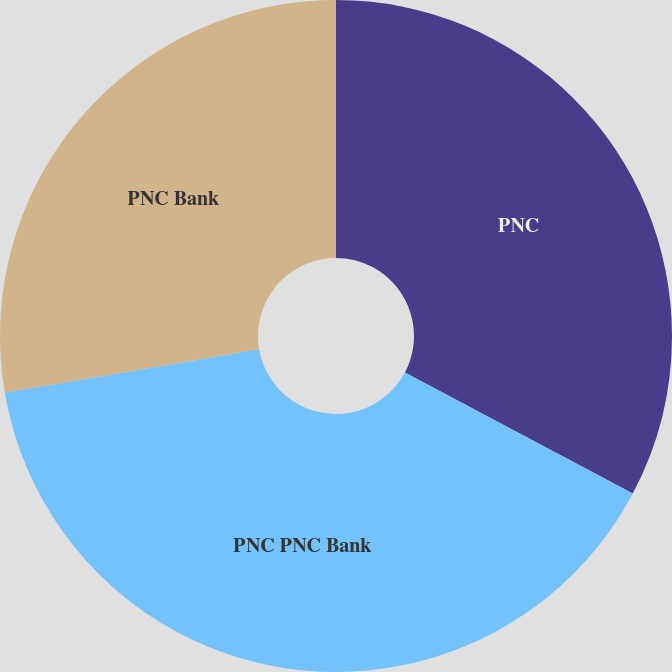Convert chart. <chart><loc_0><loc_0><loc_500><loc_500><pie_chart><fcel>PNC<fcel>PNC PNC Bank<fcel>PNC Bank<nl><fcel>32.77%<fcel>39.53%<fcel>27.7%<nl></chart> 